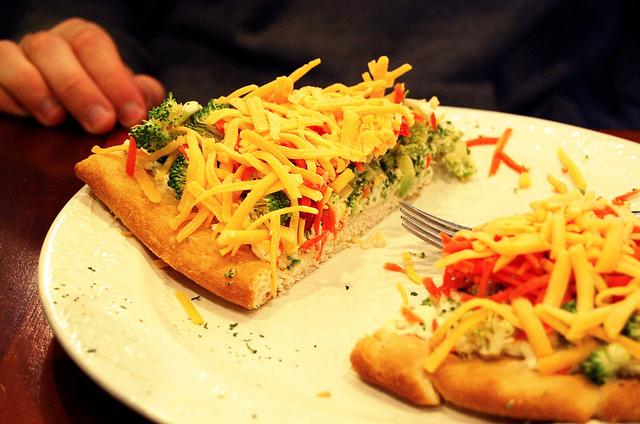How many slices of pizza do you see?
Short answer required. 2. What toppings are on the pizza?
Give a very brief answer. Cheese, broccoli, carrots. Where is the fork?
Give a very brief answer. Plate. Does the pizza slice on the right have pepperoni on it?
Write a very short answer. No. Is the persons right or left hand by the plate?
Keep it brief. Right. 